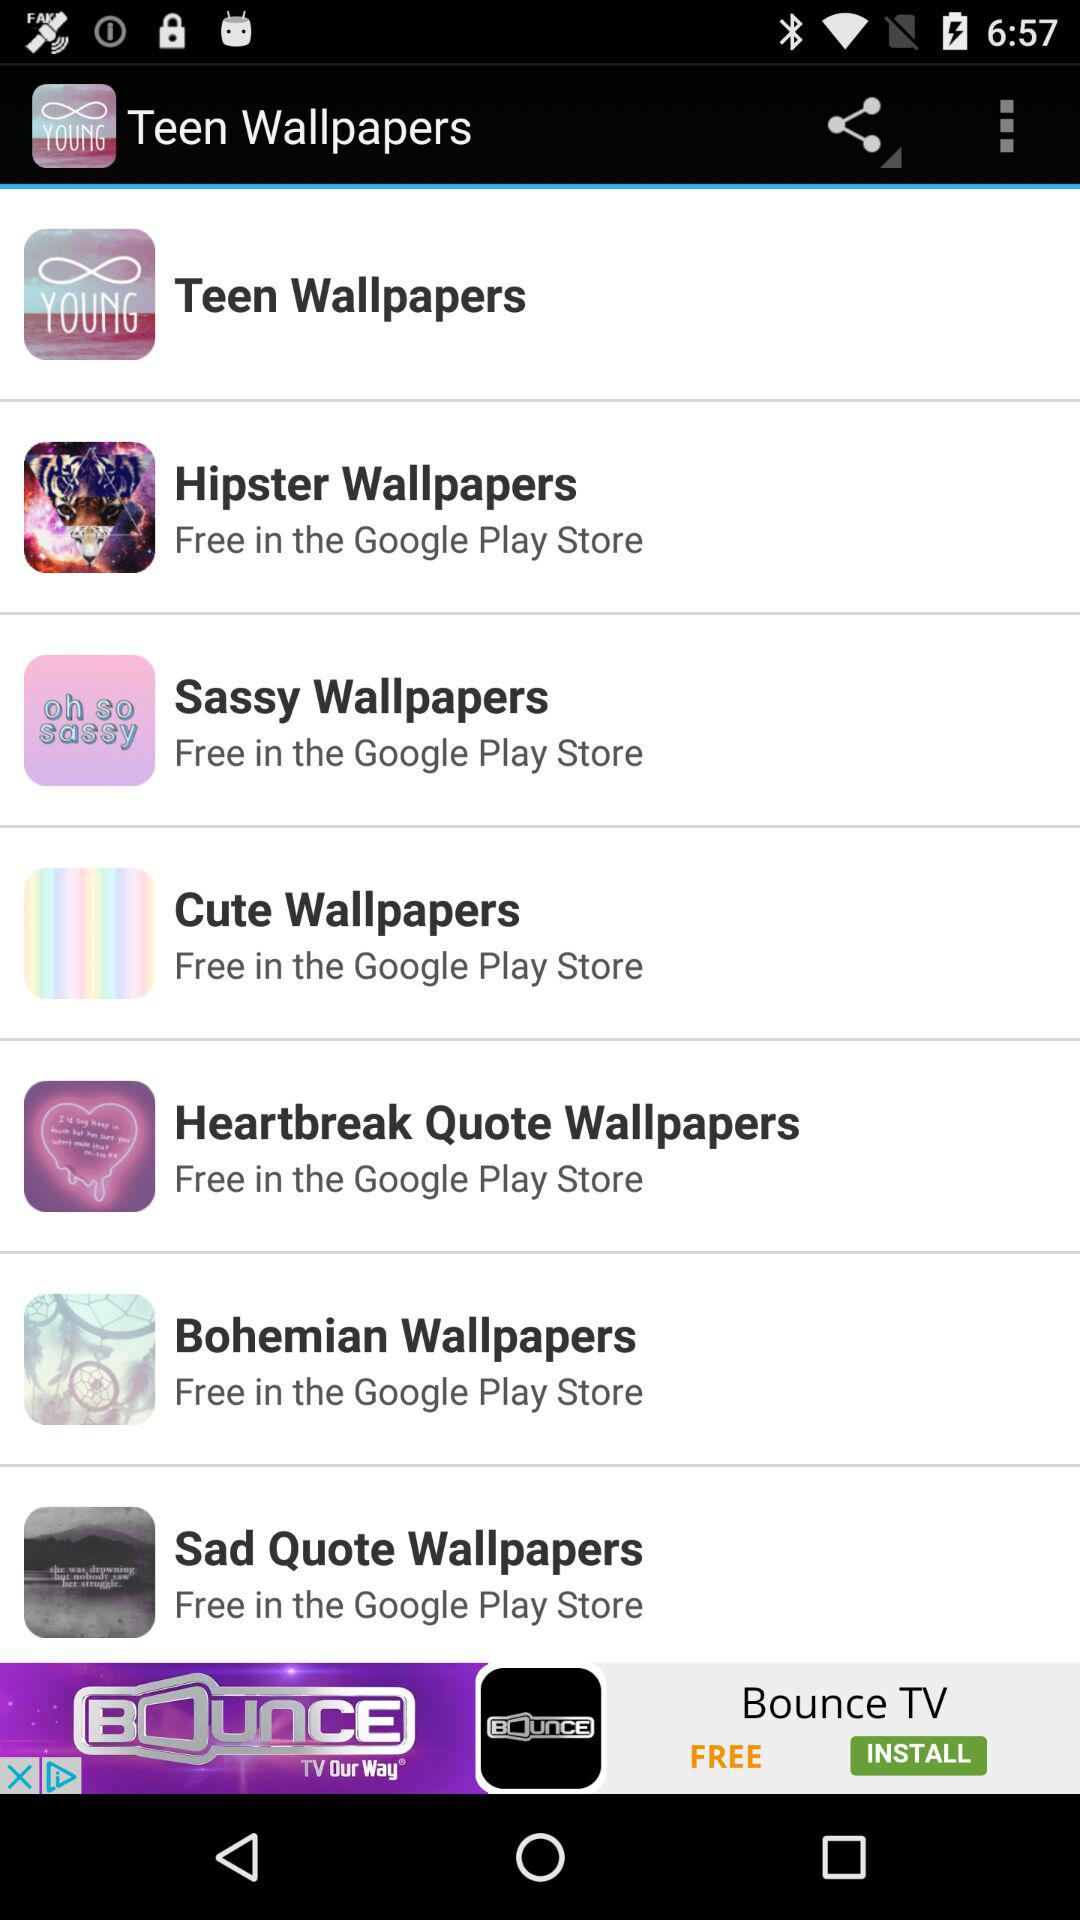What is the app name? The app names are "Teen Wallpapers", "Hipster Wallpapers", "Sassy Wallpapers", "Cute Wallpapers", "Heartbreak Quote Wallpapers", "Bohemian Wallpapers" and "Sad Quote Wallpapers". 